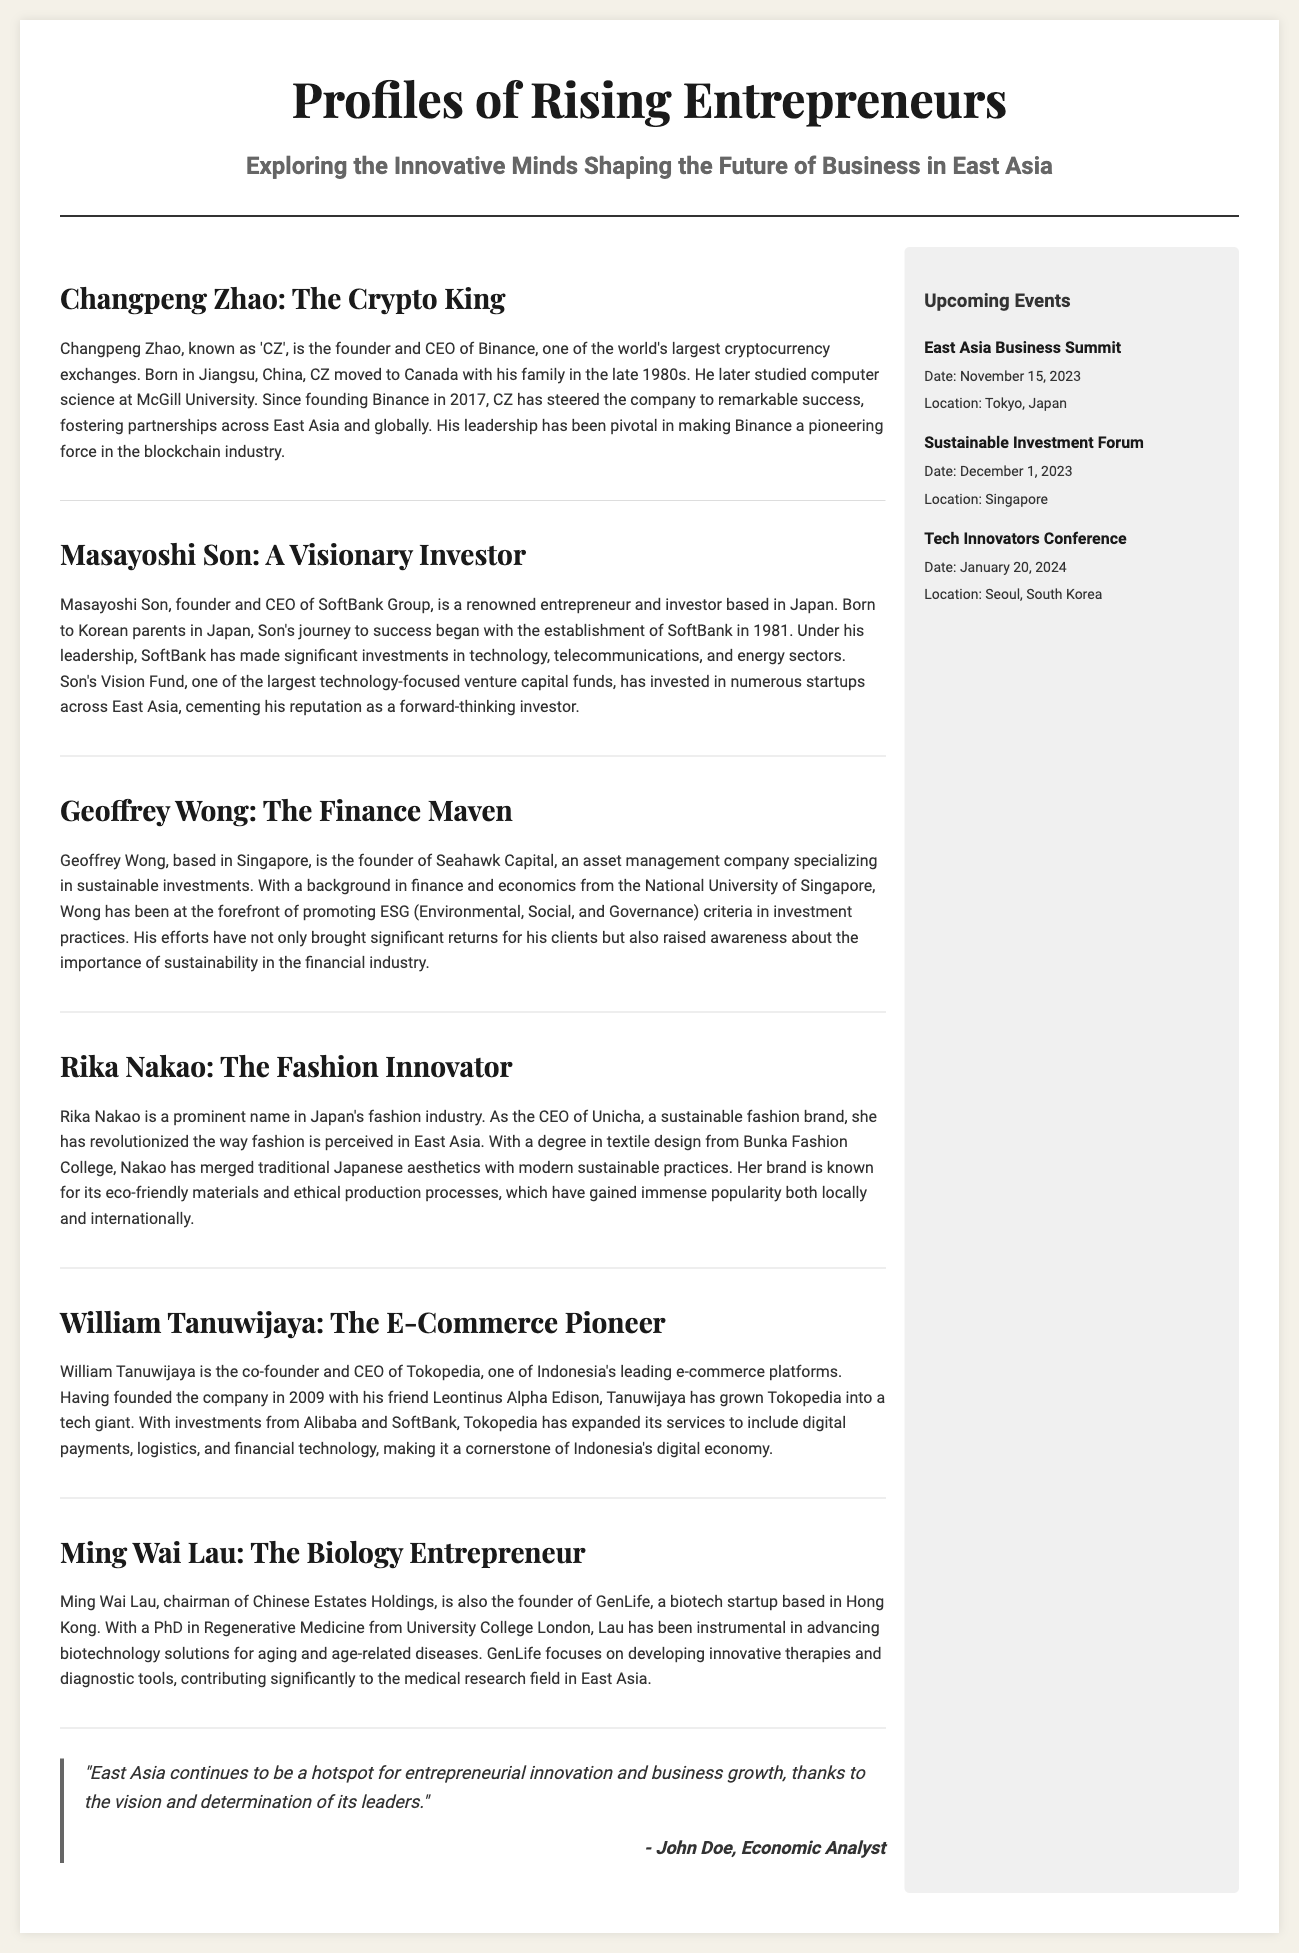What is the main focus of the article? The article focuses on the profiles of rising entrepreneurs in East Asia and their impact on business innovation.
Answer: Rising entrepreneurs Who is the founder and CEO of Binance? The document states Changpeng Zhao is the founder and CEO of Binance.
Answer: Changpeng Zhao Which country is Masayoshi Son associated with? The document indicates that Masayoshi Son is associated with Japan.
Answer: Japan What is the date of the East Asia Business Summit? The document provides the date of the East Asia Business Summit as November 15, 2023.
Answer: November 15, 2023 What significant investment is associated with SoftBank's Vision Fund? The document mentions that the Vision Fund has invested in numerous startups across East Asia.
Answer: Startups Why is Rika Nakao noted in the article? The article highlights Rika Nakao for her role in revolutionizing sustainable fashion in East Asia.
Answer: Sustainable fashion Which event is scheduled for January 20, 2024? The document specifies that the Tech Innovators Conference is scheduled for January 20, 2024.
Answer: Tech Innovators Conference What city will host the Sustainable Investment Forum? The document states that the Sustainable Investment Forum will be held in Singapore.
Answer: Singapore 